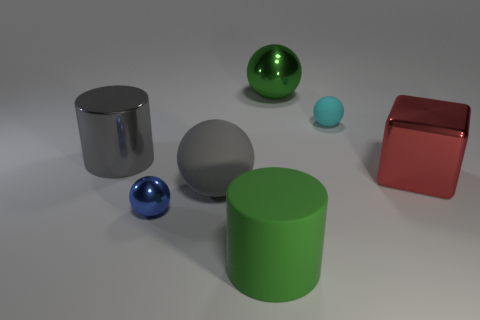Are there any things that have the same color as the large metal cylinder?
Give a very brief answer. Yes. There is a metal cylinder; is it the same color as the large sphere in front of the shiny block?
Give a very brief answer. Yes. Is the material of the cyan object the same as the big green thing that is behind the gray cylinder?
Ensure brevity in your answer.  No. What material is the cylinder that is the same color as the large metallic sphere?
Make the answer very short. Rubber. What is the size of the cylinder on the right side of the big matte thing to the left of the green rubber cylinder?
Keep it short and to the point. Large. What number of tiny things are either purple metal cylinders or green metallic spheres?
Provide a short and direct response. 0. Are there fewer green rubber cylinders than small red shiny things?
Provide a short and direct response. No. Do the big matte cylinder and the big metallic ball have the same color?
Keep it short and to the point. Yes. Are there more red metal things than small cyan cylinders?
Your answer should be compact. Yes. How many other objects are there of the same color as the small rubber ball?
Offer a very short reply. 0. 